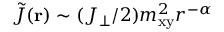<formula> <loc_0><loc_0><loc_500><loc_500>\tilde { J } ( r ) \sim ( J _ { \perp } / 2 ) m _ { x y } ^ { 2 } r ^ { - \alpha }</formula> 